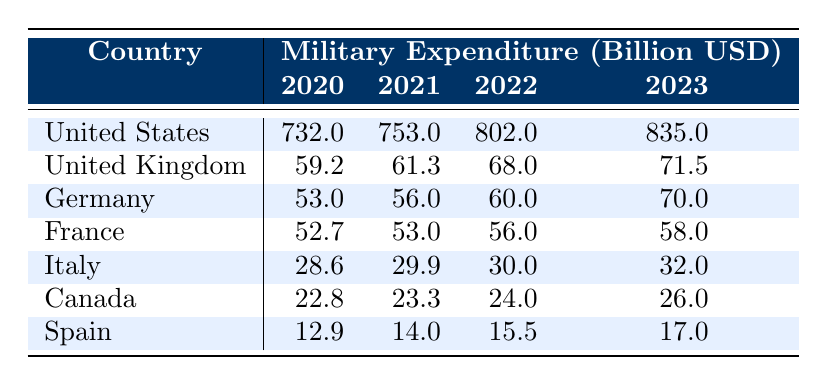What was the military expenditure of Germany in 2022? According to the table, the military expenditure of Germany for the year 2022 is listed as 60.0 billion USD.
Answer: 60.0 billion USD What was the increase in military spending for the United Kingdom from 2021 to 2023? The military expenditure for the United Kingdom in 2021 is 61.3 billion USD and in 2023 it is 71.5 billion USD. The increase is calculated as 71.5 - 61.3 = 10.2 billion USD.
Answer: 10.2 billion USD Did Canada spend more on military in 2023 than Italy? The military expenditure for Canada in 2023 is 26.0 billion USD, while for Italy it is 32.0 billion USD. Since 26.0 is less than 32.0, the answer is no.
Answer: No Which country had the highest military expenditure in 2020? The table shows that the United States had the highest military expenditure in 2020, reported as 732.0 billion USD, which is significantly higher than any other NATO country listed.
Answer: United States What was the average military expenditure of all listed countries in 2023? To find the average for 2023, first sum the expenditures: 835.0 (US) + 71.5 (UK) + 70.0 (Germany) + 58.0 (France) + 32.0 (Italy) + 26.0 (Canada) + 17.0 (Spain) = 1,109.5 billion USD. There are 7 countries, so the average is 1,109.5 / 7 = approximately 158.5 billion USD.
Answer: 158.5 billion USD How much more did the United States spend on military in 2023 compared to France? The military expenditure for the United States in 2023 is 835.0 billion USD and for France, it is 58.0 billion USD. The difference is 835.0 - 58.0 = 777.0 billion USD.
Answer: 777.0 billion USD Is the military expenditure of Germany in 2023 greater than that of Spain? Germany's military expenditure in 2023 is 70.0 billion USD, whereas Spain's expenditure is 17.0 billion USD. Since 70.0 is greater than 17.0, the answer is yes.
Answer: Yes Which year saw the highest total military expenditure across all countries? To determine the year with the highest total, calculate the total for each year: For 2020 = 732.0 + 59.2 + 53.0 + 52.7 + 28.6 + 22.8 + 12.9 = 959.2 billion USD; for 2021 = 753.0 + 61.3 + 56.0 + 53.0 + 29.9 + 23.3 + 14.0 = 960.5 billion USD; for 2022 = 802.0 + 68.0 + 60.0 + 56.0 + 30.0 + 24.0 + 15.5 = 1055.5 billion USD; for 2023 = 835.0 + 71.5 + 70.0 + 58.0 + 32.0 + 26.0 + 17.0 = 1,109.5 billion USD. 2023 has the highest total with 1,109.5 billion USD.
Answer: 2023 